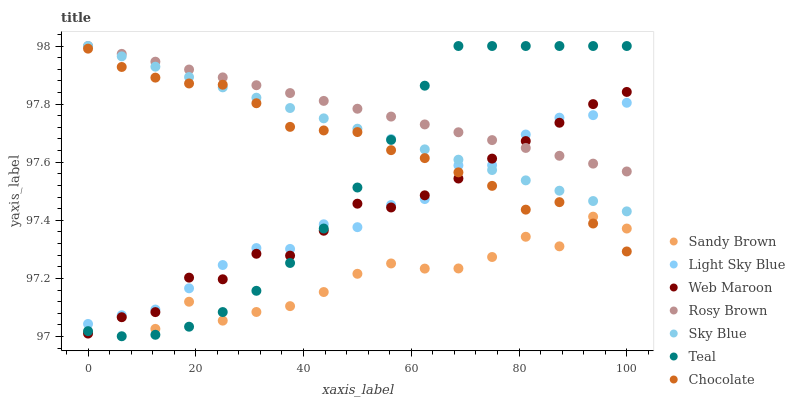Does Sandy Brown have the minimum area under the curve?
Answer yes or no. Yes. Does Rosy Brown have the maximum area under the curve?
Answer yes or no. Yes. Does Web Maroon have the minimum area under the curve?
Answer yes or no. No. Does Web Maroon have the maximum area under the curve?
Answer yes or no. No. Is Sky Blue the smoothest?
Answer yes or no. Yes. Is Sandy Brown the roughest?
Answer yes or no. Yes. Is Web Maroon the smoothest?
Answer yes or no. No. Is Web Maroon the roughest?
Answer yes or no. No. Does Teal have the lowest value?
Answer yes or no. Yes. Does Web Maroon have the lowest value?
Answer yes or no. No. Does Sky Blue have the highest value?
Answer yes or no. Yes. Does Web Maroon have the highest value?
Answer yes or no. No. Is Sandy Brown less than Rosy Brown?
Answer yes or no. Yes. Is Rosy Brown greater than Chocolate?
Answer yes or no. Yes. Does Sky Blue intersect Rosy Brown?
Answer yes or no. Yes. Is Sky Blue less than Rosy Brown?
Answer yes or no. No. Is Sky Blue greater than Rosy Brown?
Answer yes or no. No. Does Sandy Brown intersect Rosy Brown?
Answer yes or no. No. 